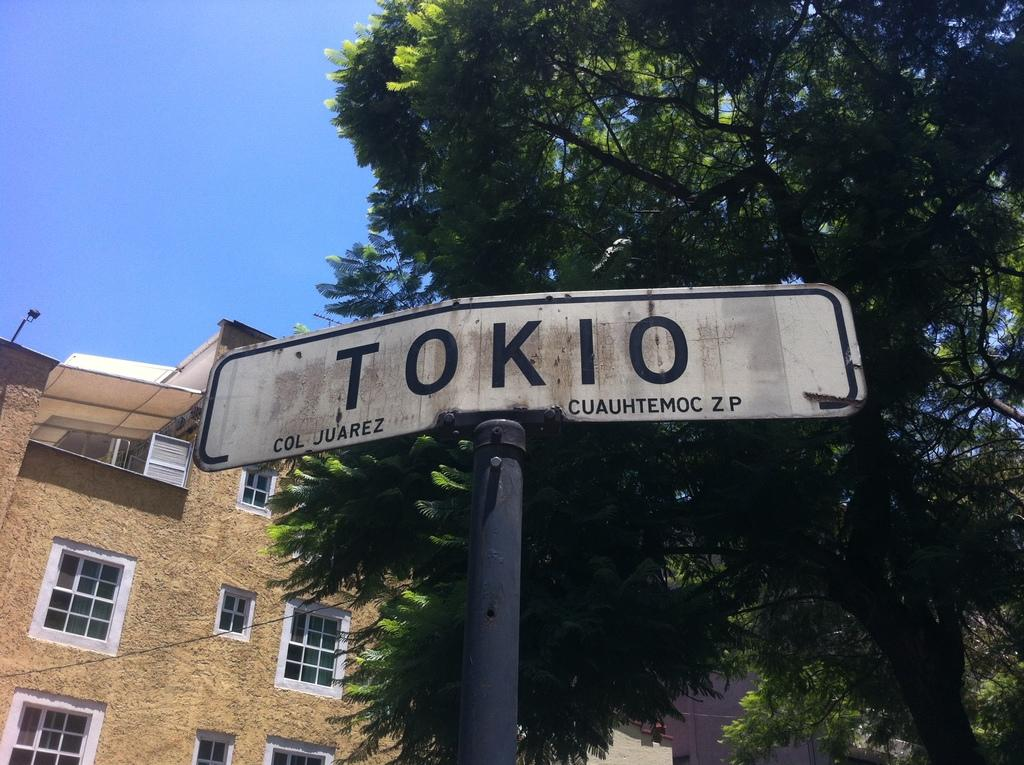What is attached to the pole in the image? There is a board attached to the pole in the image. What can be seen behind the pole? There are trees behind the pole. What else is visible in the background of the image? There are buildings visible in the background. What part of the natural environment is visible in the image? The sky is visible in the image. What type of stove can be seen in the image? There is no stove present in the image. What part of the brain is visible in the image? There is no brain present in the image. 